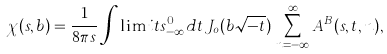Convert formula to latex. <formula><loc_0><loc_0><loc_500><loc_500>\chi ( s , b ) = \frac { 1 } { 8 \pi s } \int \lim i t s _ { - \infty } ^ { 0 } d t \, J _ { o } ( b \sqrt { - t } ) \, \sum _ { n = - \infty } ^ { \infty } A ^ { B } ( s , t , n ) ,</formula> 